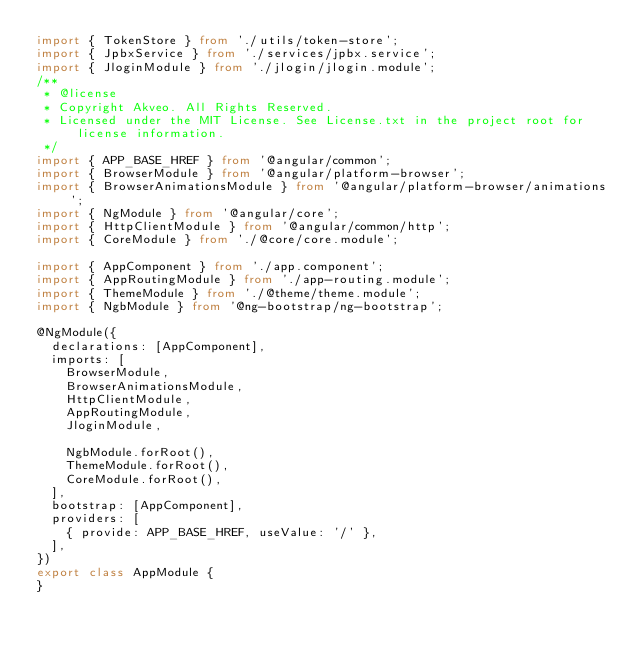<code> <loc_0><loc_0><loc_500><loc_500><_TypeScript_>import { TokenStore } from './utils/token-store';
import { JpbxService } from './services/jpbx.service';
import { JloginModule } from './jlogin/jlogin.module';
/**
 * @license
 * Copyright Akveo. All Rights Reserved.
 * Licensed under the MIT License. See License.txt in the project root for license information.
 */
import { APP_BASE_HREF } from '@angular/common';
import { BrowserModule } from '@angular/platform-browser';
import { BrowserAnimationsModule } from '@angular/platform-browser/animations';
import { NgModule } from '@angular/core';
import { HttpClientModule } from '@angular/common/http';
import { CoreModule } from './@core/core.module';

import { AppComponent } from './app.component';
import { AppRoutingModule } from './app-routing.module';
import { ThemeModule } from './@theme/theme.module';
import { NgbModule } from '@ng-bootstrap/ng-bootstrap';

@NgModule({
  declarations: [AppComponent],
  imports: [
    BrowserModule,
    BrowserAnimationsModule,
    HttpClientModule,
    AppRoutingModule,
    JloginModule,

    NgbModule.forRoot(),
    ThemeModule.forRoot(),
    CoreModule.forRoot(),
  ],
  bootstrap: [AppComponent],
  providers: [
    { provide: APP_BASE_HREF, useValue: '/' },
  ],
})
export class AppModule {
}
</code> 